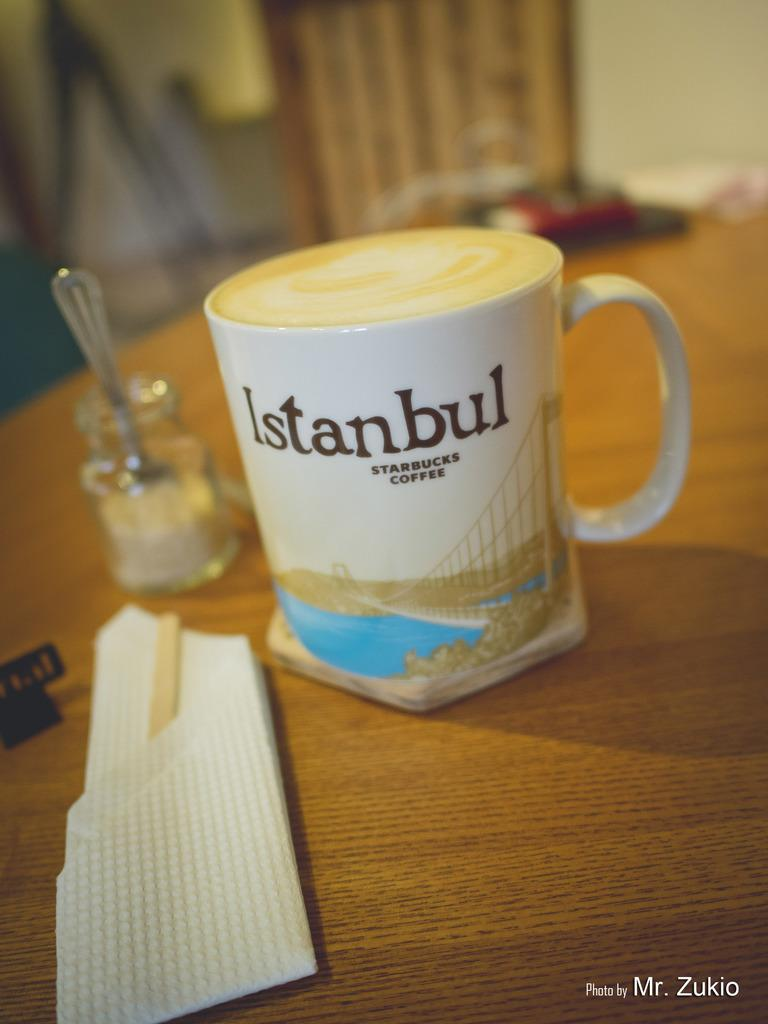<image>
Describe the image concisely. A cup of coffee sits in a mug that reads "Istanbul Starbucks Coffee" 